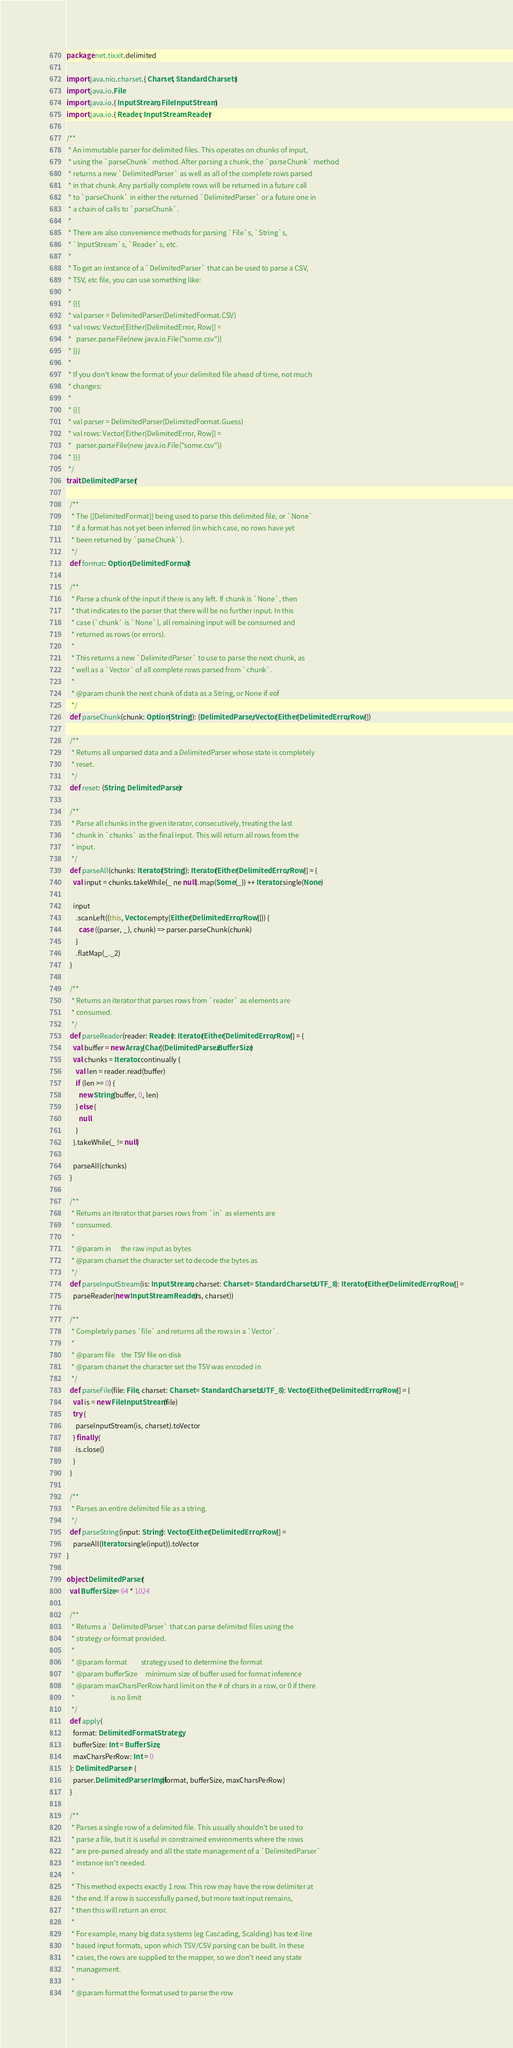<code> <loc_0><loc_0><loc_500><loc_500><_Scala_>package net.tixxit.delimited

import java.nio.charset.{ Charset, StandardCharsets }
import java.io.File
import java.io.{ InputStream, FileInputStream }
import java.io.{ Reader, InputStreamReader }

/**
 * An immutable parser for delimited files. This operates on chunks of input,
 * using the `parseChunk` method. After parsing a chunk, the `parseChunk` method
 * returns a new `DelimitedParser` as well as all of the complete rows parsed
 * in that chunk. Any partially complete rows will be returned in a future call
 * to `parseChunk` in either the returned `DelimitedParser` or a future one in
 * a chain of calls to `parseChunk`.
 *
 * There are also convenience methods for parsing `File`s, `String`s,
 * `InputStream`s, `Reader`s, etc.
 *
 * To get an instance of a `DelimitedParser` that can be used to parse a CSV,
 * TSV, etc file, you can use something like:
 *
 * {{{
 * val parser = DelimitedParser(DelimitedFormat.CSV)
 * val rows: Vector[Either[DelimitedError, Row]] =
 *   parser.parseFile(new java.io.File("some.csv"))
 * }}}
 *
 * If you don't know the format of your delimited file ahead of time, not much
 * changes:
 *
 * {{{
 * val parser = DelimitedParser(DelimitedFormat.Guess)
 * val rows: Vector[Either[DelimitedError, Row]] =
 *   parser.parseFile(new java.io.File("some.csv"))
 * }}}
 */
trait DelimitedParser {

  /**
   * The [[DelimitedFormat]] being used to parse this delimited file, or `None`
   * if a format has not yet been inferred (in which case, no rows have yet
   * been returned by `parseChunk`).
   */
  def format: Option[DelimitedFormat]

  /**
   * Parse a chunk of the input if there is any left. If chunk is `None`, then
   * that indicates to the parser that there will be no further input. In this
   * case (`chunk` is `None`), all remaining input will be consumed and
   * returned as rows (or errors).
   *
   * This returns a new `DelimitedParser` to use to parse the next chunk, as
   * well as a `Vector` of all complete rows parsed from `chunk`.
   *
   * @param chunk the next chunk of data as a String, or None if eof
   */
  def parseChunk(chunk: Option[String]): (DelimitedParser, Vector[Either[DelimitedError, Row]])

  /**
   * Returns all unparsed data and a DelimitedParser whose state is completely
   * reset.
   */
  def reset: (String, DelimitedParser)

  /**
   * Parse all chunks in the given iterator, consecutively, treating the last
   * chunk in `chunks` as the final input. This will return all rows from the
   * input.
   */
  def parseAll(chunks: Iterator[String]): Iterator[Either[DelimitedError, Row]] = {
    val input = chunks.takeWhile(_ ne null).map(Some(_)) ++ Iterator.single(None)

    input
      .scanLeft((this, Vector.empty[Either[DelimitedError, Row]])) {
        case ((parser, _), chunk) => parser.parseChunk(chunk)
      }
      .flatMap(_._2)
  }

  /**
   * Returns an iterator that parses rows from `reader` as elements are
   * consumed.
   */
  def parseReader(reader: Reader): Iterator[Either[DelimitedError, Row]] = {
    val buffer = new Array[Char](DelimitedParser.BufferSize)
    val chunks = Iterator.continually {
      val len = reader.read(buffer)
      if (len >= 0) {
        new String(buffer, 0, len)
      } else {
        null
      }
    }.takeWhile(_ != null)

    parseAll(chunks)
  }

  /**
   * Returns an iterator that parses rows from `in` as elements are
   * consumed.
   *
   * @param in      the raw input as bytes
   * @param charset the character set to decode the bytes as
   */
  def parseInputStream(is: InputStream, charset: Charset = StandardCharsets.UTF_8): Iterator[Either[DelimitedError, Row]] =
    parseReader(new InputStreamReader(is, charset))

  /**
   * Completely parses `file` and returns all the rows in a `Vector`.
   *
   * @param file    the TSV file on disk
   * @param charset the character set the TSV was encoded in
   */
  def parseFile(file: File, charset: Charset = StandardCharsets.UTF_8): Vector[Either[DelimitedError, Row]] = {
    val is = new FileInputStream(file)
    try {
      parseInputStream(is, charset).toVector
    } finally {
      is.close()
    }
  }

  /**
   * Parses an entire delimited file as a string.
   */
  def parseString(input: String): Vector[Either[DelimitedError, Row]] =
    parseAll(Iterator.single(input)).toVector
}

object DelimitedParser {
  val BufferSize = 64 * 1024

  /**
   * Returns a `DelimitedParser` that can parse delimited files using the
   * strategy or format provided.
   *
   * @param format         strategy used to determine the format
   * @param bufferSize     minimum size of buffer used for format inference
   * @param maxCharsPerRow hard limit on the # of chars in a row, or 0 if there
   *                       is no limit
   */
  def apply(
    format: DelimitedFormatStrategy,
    bufferSize: Int = BufferSize,
    maxCharsPerRow: Int = 0
  ): DelimitedParser = {
    parser.DelimitedParserImpl(format, bufferSize, maxCharsPerRow)
  }

  /**
   * Parses a single row of a delimited file. This usually shouldn't be used to
   * parse a file, but it is useful in constrained environments where the rows
   * are pre-parsed already and all the state management of a `DelimitedParser`
   * instance isn't needed.
   *
   * This method expects exactly 1 row. This row may have the row delimiter at
   * the end. If a row is successfully parsed, but more text input remains,
   * then this will return an error.
   *
   * For example, many big data systems (eg Cascading, Scalding) has text-line
   * based input formats, upon which TSV/CSV parsing can be built. In these
   * cases, the rows are supplied to the mapper, so we don't need any state
   * management.
   *
   * @param format the format used to parse the row</code> 